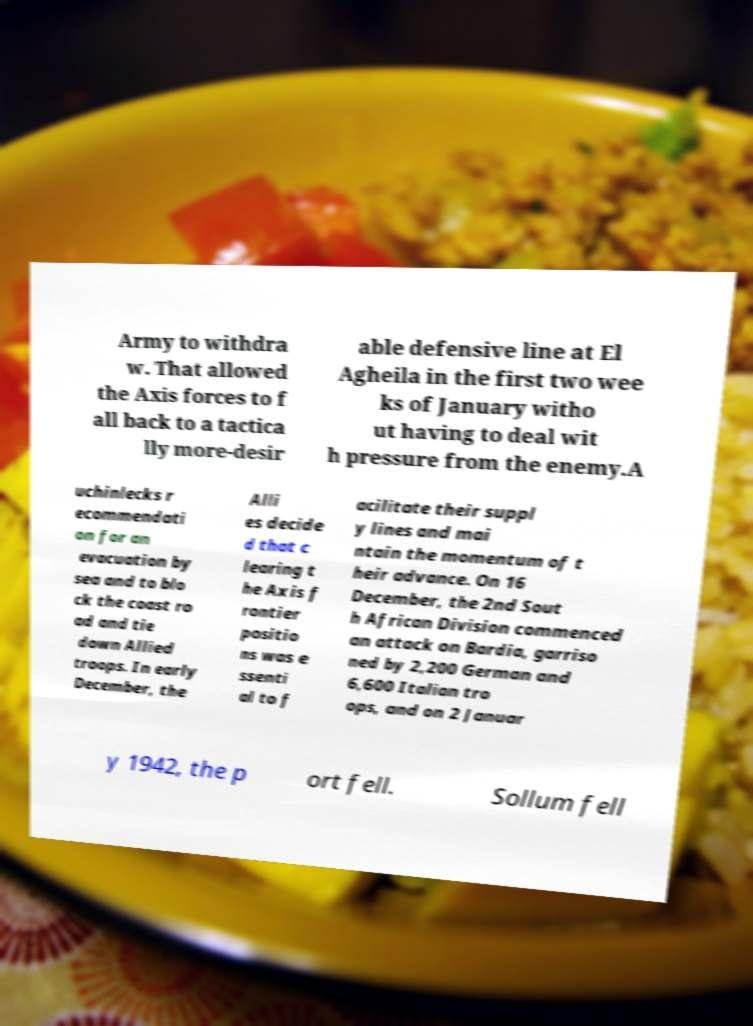What messages or text are displayed in this image? I need them in a readable, typed format. Army to withdra w. That allowed the Axis forces to f all back to a tactica lly more-desir able defensive line at El Agheila in the first two wee ks of January witho ut having to deal wit h pressure from the enemy.A uchinlecks r ecommendati on for an evacuation by sea and to blo ck the coast ro ad and tie down Allied troops. In early December, the Alli es decide d that c learing t he Axis f rontier positio ns was e ssenti al to f acilitate their suppl y lines and mai ntain the momentum of t heir advance. On 16 December, the 2nd Sout h African Division commenced an attack on Bardia, garriso ned by 2,200 German and 6,600 Italian tro ops, and on 2 Januar y 1942, the p ort fell. Sollum fell 